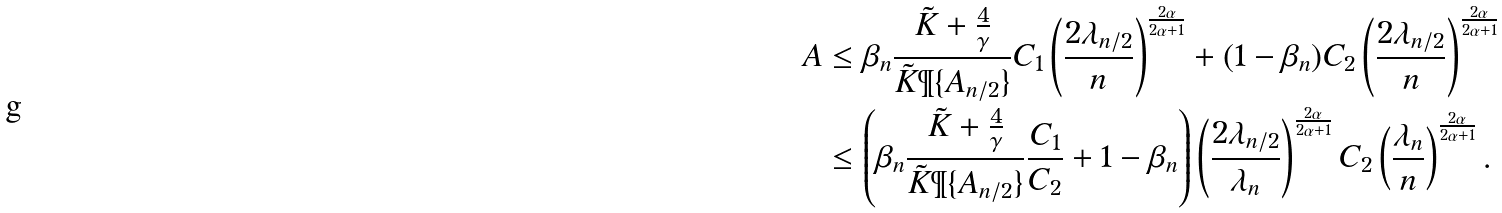Convert formula to latex. <formula><loc_0><loc_0><loc_500><loc_500>A & \leq \beta _ { n } \frac { \tilde { K } + \frac { 4 } { \gamma } } { \tilde { K } \P \{ A _ { n / 2 } \} } C _ { 1 } \left ( \frac { 2 \lambda _ { n / 2 } } { n } \right ) ^ { \frac { 2 \alpha } { 2 \alpha + 1 } } + ( 1 - \beta _ { n } ) C _ { 2 } \left ( \frac { 2 \lambda _ { n / 2 } } { n } \right ) ^ { \frac { 2 \alpha } { 2 \alpha + 1 } } \\ & \leq \left ( \beta _ { n } \frac { \tilde { K } + \frac { 4 } { \gamma } } { \tilde { K } \P \{ A _ { n / 2 } \} } \frac { C _ { 1 } } { C _ { 2 } } + 1 - \beta _ { n } \right ) \left ( \frac { 2 \lambda _ { n / 2 } } { \lambda _ { n } } \right ) ^ { \frac { 2 \alpha } { 2 \alpha + 1 } } C _ { 2 } \left ( \frac { \lambda _ { n } } { n } \right ) ^ { \frac { 2 \alpha } { 2 \alpha + 1 } } .</formula> 